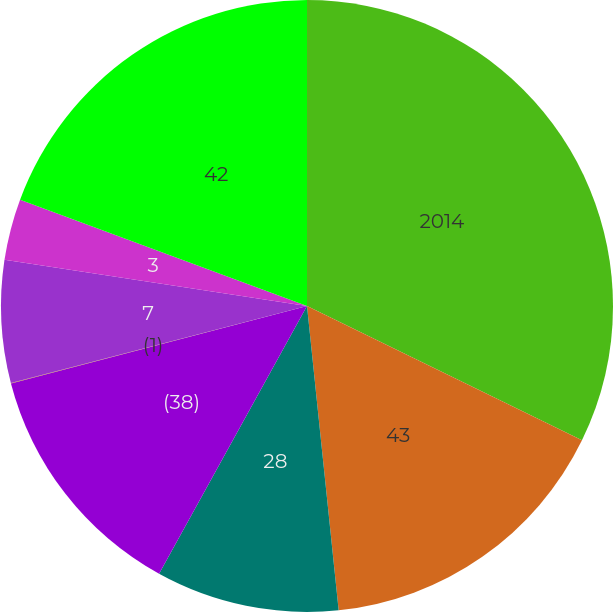Convert chart. <chart><loc_0><loc_0><loc_500><loc_500><pie_chart><fcel>2014<fcel>43<fcel>28<fcel>(38)<fcel>(1)<fcel>7<fcel>3<fcel>42<nl><fcel>32.23%<fcel>16.12%<fcel>9.68%<fcel>12.9%<fcel>0.02%<fcel>6.46%<fcel>3.24%<fcel>19.35%<nl></chart> 